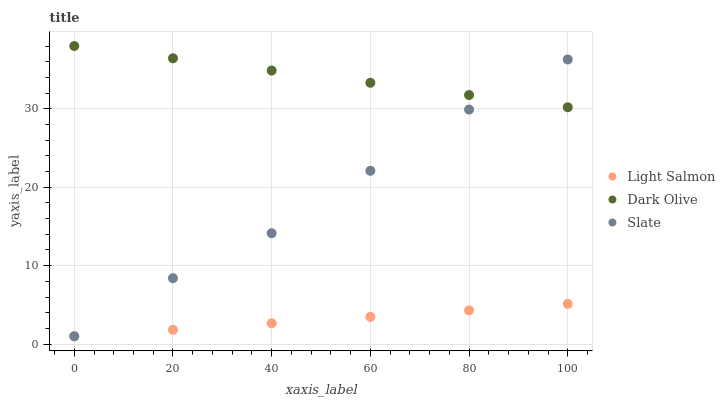Does Light Salmon have the minimum area under the curve?
Answer yes or no. Yes. Does Dark Olive have the maximum area under the curve?
Answer yes or no. Yes. Does Slate have the minimum area under the curve?
Answer yes or no. No. Does Slate have the maximum area under the curve?
Answer yes or no. No. Is Light Salmon the smoothest?
Answer yes or no. Yes. Is Slate the roughest?
Answer yes or no. Yes. Is Dark Olive the smoothest?
Answer yes or no. No. Is Dark Olive the roughest?
Answer yes or no. No. Does Light Salmon have the lowest value?
Answer yes or no. Yes. Does Dark Olive have the lowest value?
Answer yes or no. No. Does Dark Olive have the highest value?
Answer yes or no. Yes. Does Slate have the highest value?
Answer yes or no. No. Is Light Salmon less than Dark Olive?
Answer yes or no. Yes. Is Dark Olive greater than Light Salmon?
Answer yes or no. Yes. Does Dark Olive intersect Slate?
Answer yes or no. Yes. Is Dark Olive less than Slate?
Answer yes or no. No. Is Dark Olive greater than Slate?
Answer yes or no. No. Does Light Salmon intersect Dark Olive?
Answer yes or no. No. 